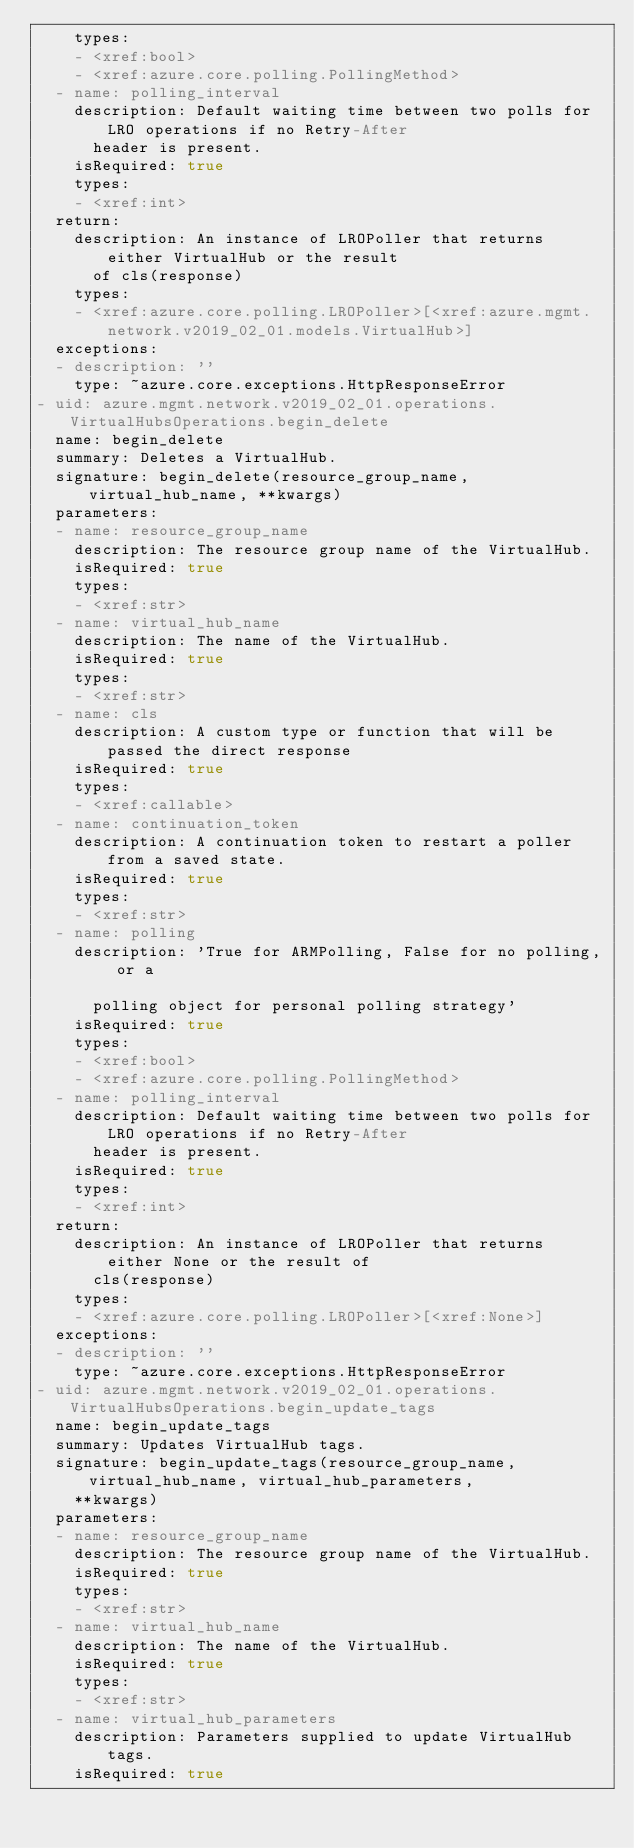Convert code to text. <code><loc_0><loc_0><loc_500><loc_500><_YAML_>    types:
    - <xref:bool>
    - <xref:azure.core.polling.PollingMethod>
  - name: polling_interval
    description: Default waiting time between two polls for LRO operations if no Retry-After
      header is present.
    isRequired: true
    types:
    - <xref:int>
  return:
    description: An instance of LROPoller that returns either VirtualHub or the result
      of cls(response)
    types:
    - <xref:azure.core.polling.LROPoller>[<xref:azure.mgmt.network.v2019_02_01.models.VirtualHub>]
  exceptions:
  - description: ''
    type: ~azure.core.exceptions.HttpResponseError
- uid: azure.mgmt.network.v2019_02_01.operations.VirtualHubsOperations.begin_delete
  name: begin_delete
  summary: Deletes a VirtualHub.
  signature: begin_delete(resource_group_name, virtual_hub_name, **kwargs)
  parameters:
  - name: resource_group_name
    description: The resource group name of the VirtualHub.
    isRequired: true
    types:
    - <xref:str>
  - name: virtual_hub_name
    description: The name of the VirtualHub.
    isRequired: true
    types:
    - <xref:str>
  - name: cls
    description: A custom type or function that will be passed the direct response
    isRequired: true
    types:
    - <xref:callable>
  - name: continuation_token
    description: A continuation token to restart a poller from a saved state.
    isRequired: true
    types:
    - <xref:str>
  - name: polling
    description: 'True for ARMPolling, False for no polling, or a

      polling object for personal polling strategy'
    isRequired: true
    types:
    - <xref:bool>
    - <xref:azure.core.polling.PollingMethod>
  - name: polling_interval
    description: Default waiting time between two polls for LRO operations if no Retry-After
      header is present.
    isRequired: true
    types:
    - <xref:int>
  return:
    description: An instance of LROPoller that returns either None or the result of
      cls(response)
    types:
    - <xref:azure.core.polling.LROPoller>[<xref:None>]
  exceptions:
  - description: ''
    type: ~azure.core.exceptions.HttpResponseError
- uid: azure.mgmt.network.v2019_02_01.operations.VirtualHubsOperations.begin_update_tags
  name: begin_update_tags
  summary: Updates VirtualHub tags.
  signature: begin_update_tags(resource_group_name, virtual_hub_name, virtual_hub_parameters,
    **kwargs)
  parameters:
  - name: resource_group_name
    description: The resource group name of the VirtualHub.
    isRequired: true
    types:
    - <xref:str>
  - name: virtual_hub_name
    description: The name of the VirtualHub.
    isRequired: true
    types:
    - <xref:str>
  - name: virtual_hub_parameters
    description: Parameters supplied to update VirtualHub tags.
    isRequired: true</code> 